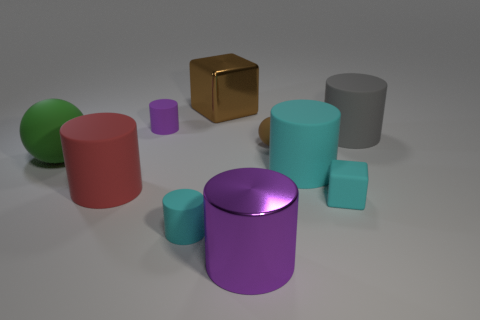Subtract 2 cylinders. How many cylinders are left? 4 Subtract all large purple metal cylinders. How many cylinders are left? 5 Subtract all purple cylinders. How many cylinders are left? 4 Subtract all brown cylinders. Subtract all purple spheres. How many cylinders are left? 6 Subtract all cylinders. How many objects are left? 4 Add 5 small purple objects. How many small purple objects exist? 6 Subtract 0 cyan spheres. How many objects are left? 10 Subtract all green objects. Subtract all cyan cubes. How many objects are left? 8 Add 2 tiny matte spheres. How many tiny matte spheres are left? 3 